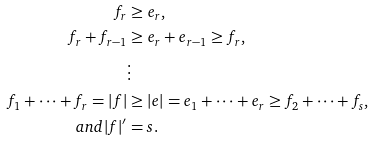Convert formula to latex. <formula><loc_0><loc_0><loc_500><loc_500>f _ { r } & \geq e _ { r } , \\ f _ { r } + f _ { r - 1 } & \geq e _ { r } + e _ { r - 1 } \geq f _ { r } , \\ & \vdots \\ f _ { 1 } + \cdots + f _ { r } = | f | & \geq | e | = e _ { 1 } + \cdots + e _ { r } \geq f _ { 2 } + \cdots + f _ { s } , \\ a n d | f | ^ { \prime } & = s .</formula> 